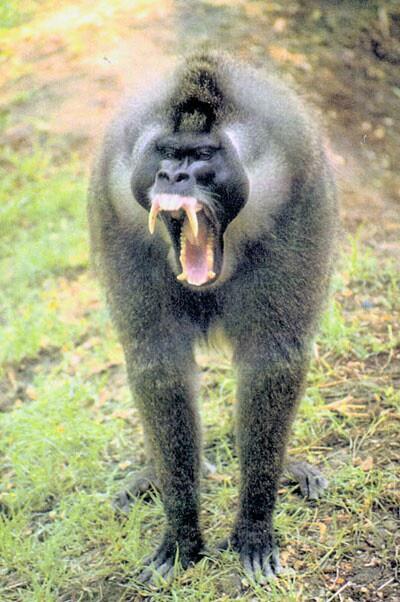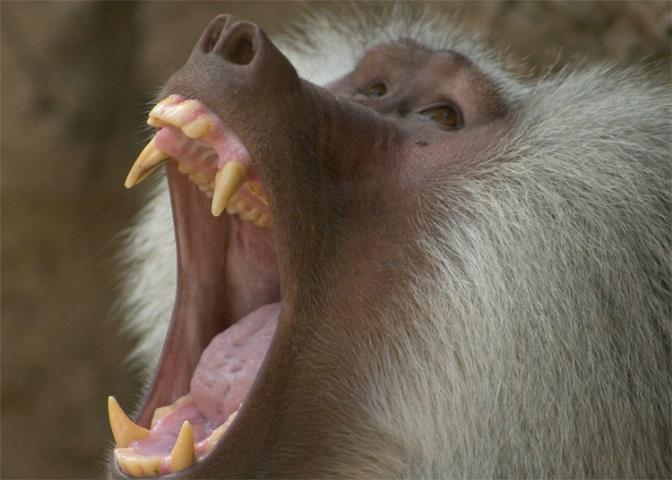The first image is the image on the left, the second image is the image on the right. Assess this claim about the two images: "Each image shows one open-mouthed, fang-baring monkey, and one image shows a monkey with an upturned snout and open mouth.". Correct or not? Answer yes or no. Yes. The first image is the image on the left, the second image is the image on the right. Analyze the images presented: Is the assertion "At least one primate is on a log or branch." valid? Answer yes or no. No. 